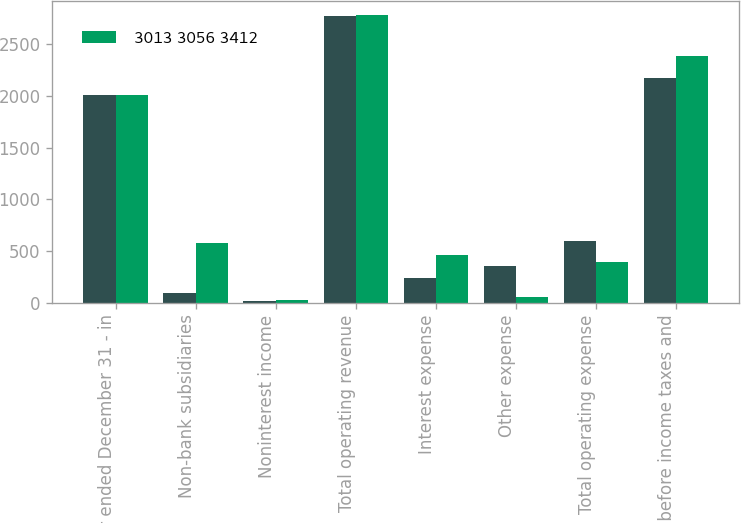Convert chart. <chart><loc_0><loc_0><loc_500><loc_500><stacked_bar_chart><ecel><fcel>Year ended December 31 - in<fcel>Non-bank subsidiaries<fcel>Noninterest income<fcel>Total operating revenue<fcel>Interest expense<fcel>Other expense<fcel>Total operating expense<fcel>Income before income taxes and<nl><fcel>nan<fcel>2012<fcel>91<fcel>22<fcel>2773<fcel>242<fcel>359<fcel>601<fcel>2172<nl><fcel>3013 3056 3412<fcel>2010<fcel>575<fcel>27<fcel>2782<fcel>458<fcel>61<fcel>397<fcel>2385<nl></chart> 